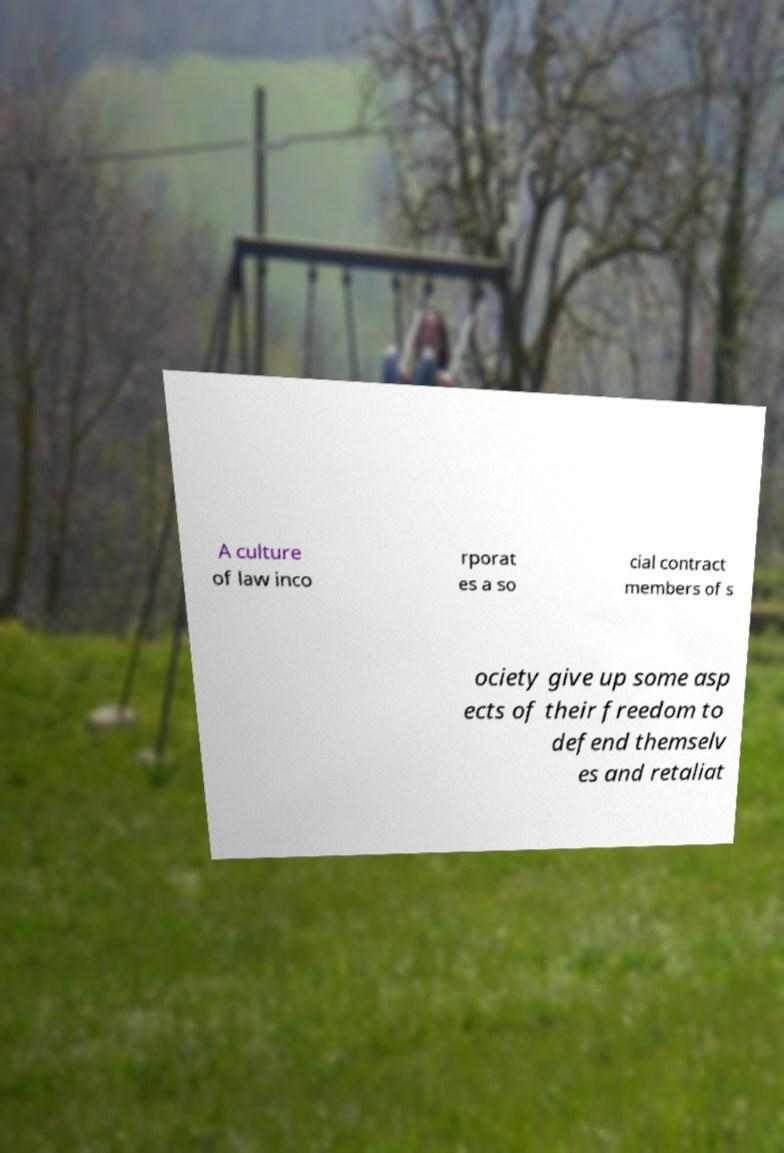Could you extract and type out the text from this image? A culture of law inco rporat es a so cial contract members of s ociety give up some asp ects of their freedom to defend themselv es and retaliat 